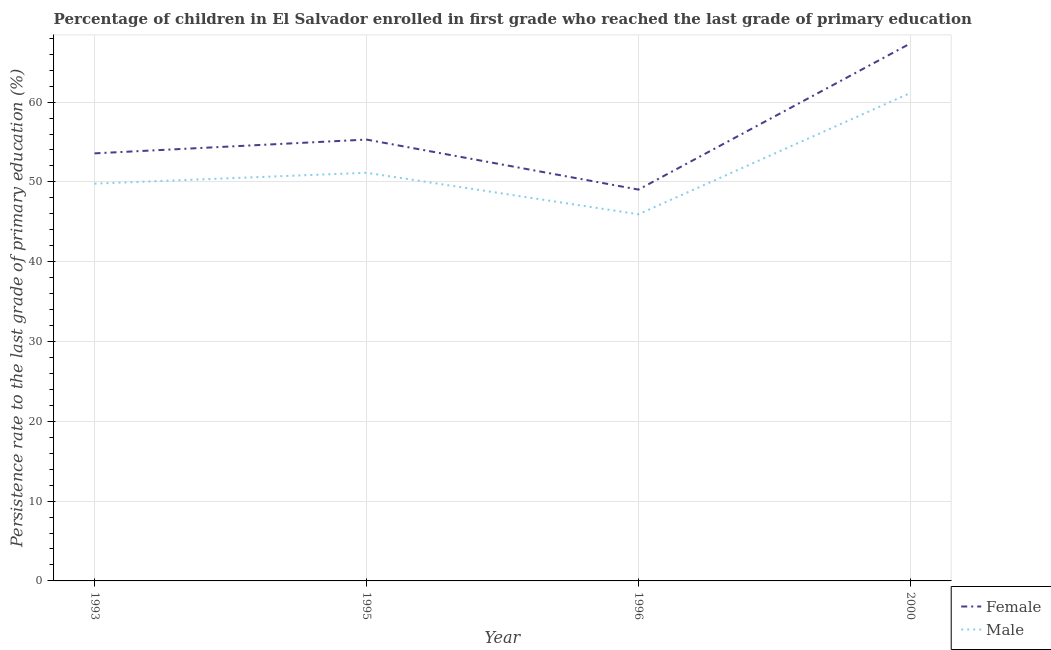How many different coloured lines are there?
Your answer should be very brief. 2. What is the persistence rate of male students in 1996?
Offer a very short reply. 45.94. Across all years, what is the maximum persistence rate of male students?
Provide a succinct answer. 61.15. Across all years, what is the minimum persistence rate of female students?
Offer a very short reply. 49.04. In which year was the persistence rate of male students minimum?
Your answer should be compact. 1996. What is the total persistence rate of female students in the graph?
Your answer should be very brief. 225.27. What is the difference between the persistence rate of female students in 1996 and that in 2000?
Provide a short and direct response. -18.32. What is the difference between the persistence rate of female students in 1993 and the persistence rate of male students in 2000?
Provide a succinct answer. -7.57. What is the average persistence rate of female students per year?
Provide a short and direct response. 56.32. In the year 1996, what is the difference between the persistence rate of female students and persistence rate of male students?
Make the answer very short. 3.09. What is the ratio of the persistence rate of female students in 1993 to that in 1995?
Keep it short and to the point. 0.97. Is the difference between the persistence rate of female students in 1993 and 2000 greater than the difference between the persistence rate of male students in 1993 and 2000?
Your answer should be compact. No. What is the difference between the highest and the second highest persistence rate of female students?
Keep it short and to the point. 12.05. What is the difference between the highest and the lowest persistence rate of female students?
Give a very brief answer. 18.32. In how many years, is the persistence rate of male students greater than the average persistence rate of male students taken over all years?
Keep it short and to the point. 1. Does the persistence rate of male students monotonically increase over the years?
Your response must be concise. No. Is the persistence rate of male students strictly less than the persistence rate of female students over the years?
Make the answer very short. Yes. How many lines are there?
Provide a short and direct response. 2. Are the values on the major ticks of Y-axis written in scientific E-notation?
Make the answer very short. No. How many legend labels are there?
Your response must be concise. 2. What is the title of the graph?
Keep it short and to the point. Percentage of children in El Salvador enrolled in first grade who reached the last grade of primary education. Does "Primary income" appear as one of the legend labels in the graph?
Your answer should be very brief. No. What is the label or title of the X-axis?
Make the answer very short. Year. What is the label or title of the Y-axis?
Offer a very short reply. Persistence rate to the last grade of primary education (%). What is the Persistence rate to the last grade of primary education (%) of Female in 1993?
Offer a very short reply. 53.58. What is the Persistence rate to the last grade of primary education (%) in Male in 1993?
Provide a short and direct response. 49.78. What is the Persistence rate to the last grade of primary education (%) of Female in 1995?
Give a very brief answer. 55.3. What is the Persistence rate to the last grade of primary education (%) of Male in 1995?
Offer a very short reply. 51.15. What is the Persistence rate to the last grade of primary education (%) in Female in 1996?
Offer a very short reply. 49.04. What is the Persistence rate to the last grade of primary education (%) of Male in 1996?
Offer a very short reply. 45.94. What is the Persistence rate to the last grade of primary education (%) in Female in 2000?
Provide a short and direct response. 67.35. What is the Persistence rate to the last grade of primary education (%) of Male in 2000?
Make the answer very short. 61.15. Across all years, what is the maximum Persistence rate to the last grade of primary education (%) in Female?
Ensure brevity in your answer.  67.35. Across all years, what is the maximum Persistence rate to the last grade of primary education (%) of Male?
Provide a succinct answer. 61.15. Across all years, what is the minimum Persistence rate to the last grade of primary education (%) in Female?
Give a very brief answer. 49.04. Across all years, what is the minimum Persistence rate to the last grade of primary education (%) in Male?
Offer a very short reply. 45.94. What is the total Persistence rate to the last grade of primary education (%) of Female in the graph?
Keep it short and to the point. 225.27. What is the total Persistence rate to the last grade of primary education (%) of Male in the graph?
Make the answer very short. 208.02. What is the difference between the Persistence rate to the last grade of primary education (%) in Female in 1993 and that in 1995?
Offer a terse response. -1.73. What is the difference between the Persistence rate to the last grade of primary education (%) of Male in 1993 and that in 1995?
Ensure brevity in your answer.  -1.36. What is the difference between the Persistence rate to the last grade of primary education (%) in Female in 1993 and that in 1996?
Provide a succinct answer. 4.54. What is the difference between the Persistence rate to the last grade of primary education (%) of Male in 1993 and that in 1996?
Give a very brief answer. 3.84. What is the difference between the Persistence rate to the last grade of primary education (%) of Female in 1993 and that in 2000?
Provide a succinct answer. -13.78. What is the difference between the Persistence rate to the last grade of primary education (%) of Male in 1993 and that in 2000?
Your answer should be very brief. -11.36. What is the difference between the Persistence rate to the last grade of primary education (%) of Female in 1995 and that in 1996?
Ensure brevity in your answer.  6.27. What is the difference between the Persistence rate to the last grade of primary education (%) of Male in 1995 and that in 1996?
Your answer should be compact. 5.2. What is the difference between the Persistence rate to the last grade of primary education (%) of Female in 1995 and that in 2000?
Your answer should be very brief. -12.05. What is the difference between the Persistence rate to the last grade of primary education (%) of Male in 1995 and that in 2000?
Your answer should be very brief. -10. What is the difference between the Persistence rate to the last grade of primary education (%) of Female in 1996 and that in 2000?
Keep it short and to the point. -18.32. What is the difference between the Persistence rate to the last grade of primary education (%) in Male in 1996 and that in 2000?
Make the answer very short. -15.2. What is the difference between the Persistence rate to the last grade of primary education (%) in Female in 1993 and the Persistence rate to the last grade of primary education (%) in Male in 1995?
Provide a short and direct response. 2.43. What is the difference between the Persistence rate to the last grade of primary education (%) in Female in 1993 and the Persistence rate to the last grade of primary education (%) in Male in 1996?
Ensure brevity in your answer.  7.63. What is the difference between the Persistence rate to the last grade of primary education (%) in Female in 1993 and the Persistence rate to the last grade of primary education (%) in Male in 2000?
Give a very brief answer. -7.57. What is the difference between the Persistence rate to the last grade of primary education (%) in Female in 1995 and the Persistence rate to the last grade of primary education (%) in Male in 1996?
Make the answer very short. 9.36. What is the difference between the Persistence rate to the last grade of primary education (%) of Female in 1995 and the Persistence rate to the last grade of primary education (%) of Male in 2000?
Offer a very short reply. -5.84. What is the difference between the Persistence rate to the last grade of primary education (%) in Female in 1996 and the Persistence rate to the last grade of primary education (%) in Male in 2000?
Your answer should be compact. -12.11. What is the average Persistence rate to the last grade of primary education (%) of Female per year?
Offer a terse response. 56.32. What is the average Persistence rate to the last grade of primary education (%) in Male per year?
Your answer should be compact. 52. In the year 1993, what is the difference between the Persistence rate to the last grade of primary education (%) in Female and Persistence rate to the last grade of primary education (%) in Male?
Make the answer very short. 3.79. In the year 1995, what is the difference between the Persistence rate to the last grade of primary education (%) of Female and Persistence rate to the last grade of primary education (%) of Male?
Offer a very short reply. 4.16. In the year 1996, what is the difference between the Persistence rate to the last grade of primary education (%) in Female and Persistence rate to the last grade of primary education (%) in Male?
Offer a very short reply. 3.09. In the year 2000, what is the difference between the Persistence rate to the last grade of primary education (%) in Female and Persistence rate to the last grade of primary education (%) in Male?
Your answer should be compact. 6.21. What is the ratio of the Persistence rate to the last grade of primary education (%) in Female in 1993 to that in 1995?
Offer a very short reply. 0.97. What is the ratio of the Persistence rate to the last grade of primary education (%) in Male in 1993 to that in 1995?
Ensure brevity in your answer.  0.97. What is the ratio of the Persistence rate to the last grade of primary education (%) in Female in 1993 to that in 1996?
Offer a very short reply. 1.09. What is the ratio of the Persistence rate to the last grade of primary education (%) of Male in 1993 to that in 1996?
Provide a succinct answer. 1.08. What is the ratio of the Persistence rate to the last grade of primary education (%) in Female in 1993 to that in 2000?
Your response must be concise. 0.8. What is the ratio of the Persistence rate to the last grade of primary education (%) of Male in 1993 to that in 2000?
Give a very brief answer. 0.81. What is the ratio of the Persistence rate to the last grade of primary education (%) in Female in 1995 to that in 1996?
Give a very brief answer. 1.13. What is the ratio of the Persistence rate to the last grade of primary education (%) of Male in 1995 to that in 1996?
Make the answer very short. 1.11. What is the ratio of the Persistence rate to the last grade of primary education (%) in Female in 1995 to that in 2000?
Your answer should be compact. 0.82. What is the ratio of the Persistence rate to the last grade of primary education (%) of Male in 1995 to that in 2000?
Give a very brief answer. 0.84. What is the ratio of the Persistence rate to the last grade of primary education (%) in Female in 1996 to that in 2000?
Give a very brief answer. 0.73. What is the ratio of the Persistence rate to the last grade of primary education (%) of Male in 1996 to that in 2000?
Your response must be concise. 0.75. What is the difference between the highest and the second highest Persistence rate to the last grade of primary education (%) of Female?
Ensure brevity in your answer.  12.05. What is the difference between the highest and the second highest Persistence rate to the last grade of primary education (%) of Male?
Keep it short and to the point. 10. What is the difference between the highest and the lowest Persistence rate to the last grade of primary education (%) of Female?
Keep it short and to the point. 18.32. What is the difference between the highest and the lowest Persistence rate to the last grade of primary education (%) of Male?
Ensure brevity in your answer.  15.2. 